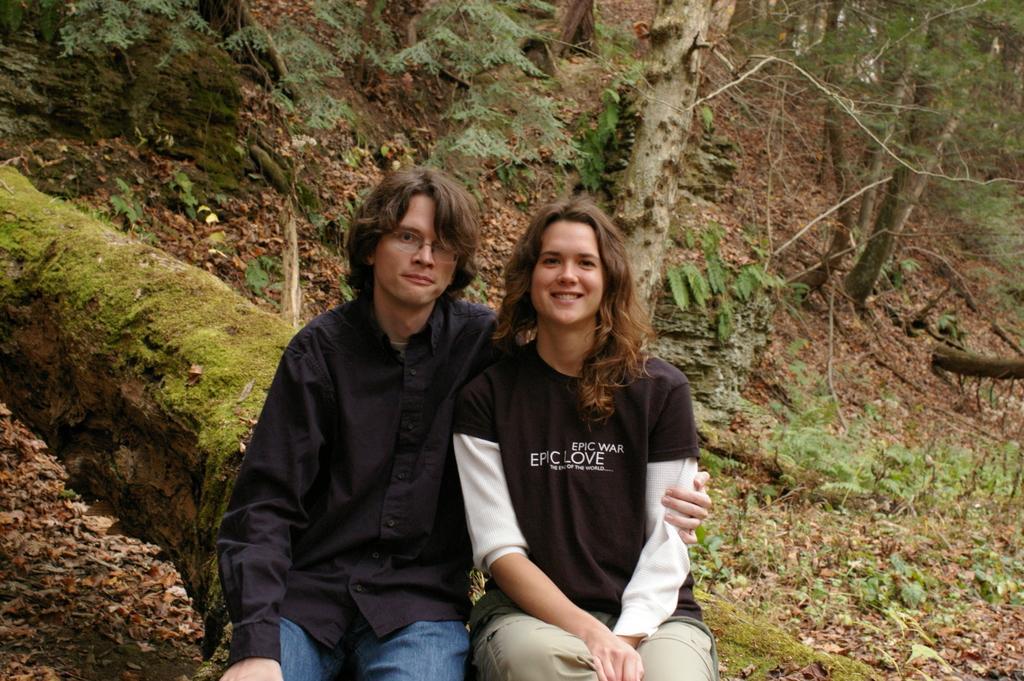How would you summarize this image in a sentence or two? In this image I see a man who is wearing black shirt and blue jeans and I see that this woman is wearing black and white t-shirt and cream color pant and I see that she is smiling and there are few words written over here and both of them are sitting and in the background I see the ground on which there are many leaves and plants and I see trees. 